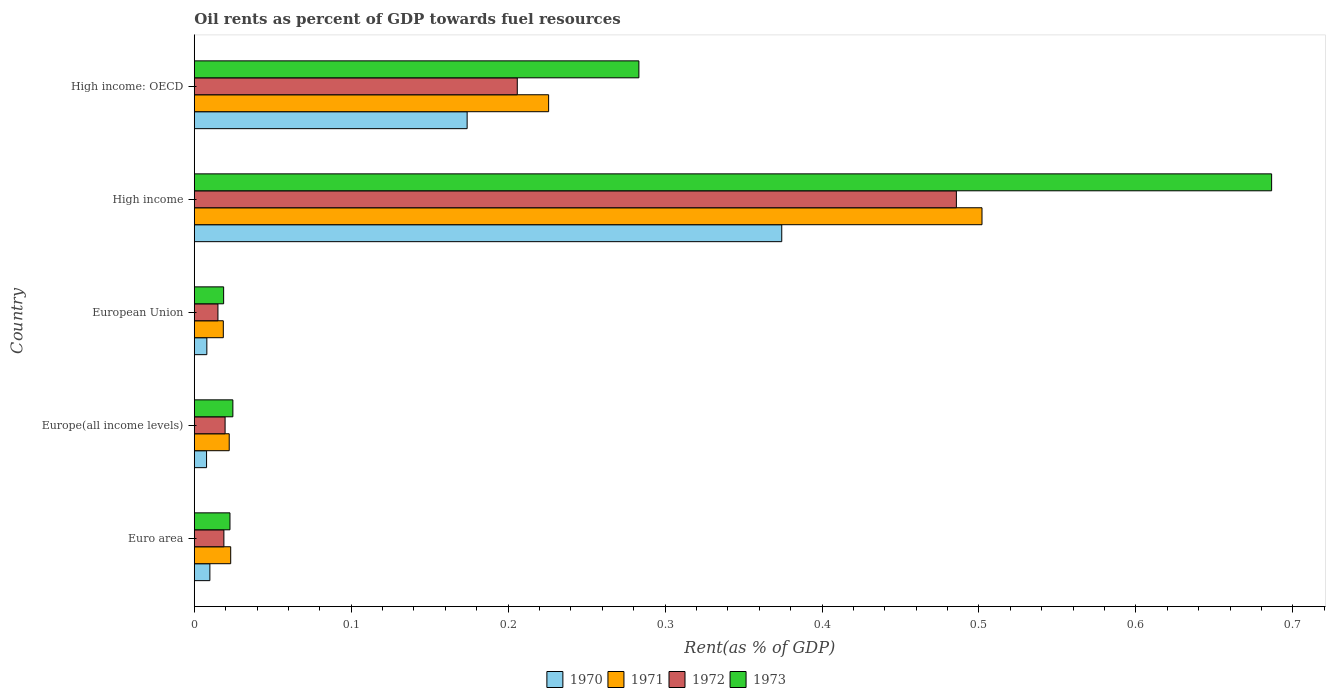How many different coloured bars are there?
Offer a very short reply. 4. Are the number of bars on each tick of the Y-axis equal?
Make the answer very short. Yes. What is the oil rent in 1971 in Euro area?
Offer a very short reply. 0.02. Across all countries, what is the maximum oil rent in 1973?
Offer a terse response. 0.69. Across all countries, what is the minimum oil rent in 1971?
Give a very brief answer. 0.02. What is the total oil rent in 1972 in the graph?
Offer a very short reply. 0.75. What is the difference between the oil rent in 1971 in Euro area and that in High income?
Provide a short and direct response. -0.48. What is the difference between the oil rent in 1970 in High income: OECD and the oil rent in 1973 in Europe(all income levels)?
Provide a short and direct response. 0.15. What is the average oil rent in 1973 per country?
Ensure brevity in your answer.  0.21. What is the difference between the oil rent in 1972 and oil rent in 1973 in High income?
Your answer should be compact. -0.2. In how many countries, is the oil rent in 1973 greater than 0.18 %?
Make the answer very short. 2. What is the ratio of the oil rent in 1970 in Euro area to that in Europe(all income levels)?
Ensure brevity in your answer.  1.27. Is the difference between the oil rent in 1972 in Europe(all income levels) and High income greater than the difference between the oil rent in 1973 in Europe(all income levels) and High income?
Make the answer very short. Yes. What is the difference between the highest and the second highest oil rent in 1970?
Ensure brevity in your answer.  0.2. What is the difference between the highest and the lowest oil rent in 1972?
Keep it short and to the point. 0.47. In how many countries, is the oil rent in 1971 greater than the average oil rent in 1971 taken over all countries?
Provide a succinct answer. 2. Is the sum of the oil rent in 1970 in Europe(all income levels) and High income: OECD greater than the maximum oil rent in 1971 across all countries?
Ensure brevity in your answer.  No. Is it the case that in every country, the sum of the oil rent in 1971 and oil rent in 1972 is greater than the sum of oil rent in 1973 and oil rent in 1970?
Ensure brevity in your answer.  No. What does the 4th bar from the top in High income: OECD represents?
Your answer should be compact. 1970. What does the 2nd bar from the bottom in Euro area represents?
Make the answer very short. 1971. Is it the case that in every country, the sum of the oil rent in 1971 and oil rent in 1973 is greater than the oil rent in 1970?
Your answer should be very brief. Yes. How many bars are there?
Your answer should be very brief. 20. Are the values on the major ticks of X-axis written in scientific E-notation?
Offer a very short reply. No. Does the graph contain grids?
Make the answer very short. No. Where does the legend appear in the graph?
Offer a terse response. Bottom center. How many legend labels are there?
Your answer should be very brief. 4. How are the legend labels stacked?
Offer a terse response. Horizontal. What is the title of the graph?
Make the answer very short. Oil rents as percent of GDP towards fuel resources. Does "1990" appear as one of the legend labels in the graph?
Offer a very short reply. No. What is the label or title of the X-axis?
Provide a short and direct response. Rent(as % of GDP). What is the Rent(as % of GDP) in 1970 in Euro area?
Your answer should be compact. 0.01. What is the Rent(as % of GDP) in 1971 in Euro area?
Your answer should be compact. 0.02. What is the Rent(as % of GDP) in 1972 in Euro area?
Give a very brief answer. 0.02. What is the Rent(as % of GDP) in 1973 in Euro area?
Provide a succinct answer. 0.02. What is the Rent(as % of GDP) in 1970 in Europe(all income levels)?
Provide a succinct answer. 0.01. What is the Rent(as % of GDP) in 1971 in Europe(all income levels)?
Provide a succinct answer. 0.02. What is the Rent(as % of GDP) of 1972 in Europe(all income levels)?
Provide a short and direct response. 0.02. What is the Rent(as % of GDP) in 1973 in Europe(all income levels)?
Offer a very short reply. 0.02. What is the Rent(as % of GDP) of 1970 in European Union?
Ensure brevity in your answer.  0.01. What is the Rent(as % of GDP) in 1971 in European Union?
Your answer should be very brief. 0.02. What is the Rent(as % of GDP) of 1972 in European Union?
Make the answer very short. 0.02. What is the Rent(as % of GDP) of 1973 in European Union?
Keep it short and to the point. 0.02. What is the Rent(as % of GDP) of 1970 in High income?
Offer a terse response. 0.37. What is the Rent(as % of GDP) of 1971 in High income?
Offer a terse response. 0.5. What is the Rent(as % of GDP) in 1972 in High income?
Offer a terse response. 0.49. What is the Rent(as % of GDP) in 1973 in High income?
Ensure brevity in your answer.  0.69. What is the Rent(as % of GDP) in 1970 in High income: OECD?
Your response must be concise. 0.17. What is the Rent(as % of GDP) of 1971 in High income: OECD?
Offer a terse response. 0.23. What is the Rent(as % of GDP) in 1972 in High income: OECD?
Offer a terse response. 0.21. What is the Rent(as % of GDP) in 1973 in High income: OECD?
Your response must be concise. 0.28. Across all countries, what is the maximum Rent(as % of GDP) in 1970?
Offer a very short reply. 0.37. Across all countries, what is the maximum Rent(as % of GDP) in 1971?
Your answer should be compact. 0.5. Across all countries, what is the maximum Rent(as % of GDP) in 1972?
Provide a short and direct response. 0.49. Across all countries, what is the maximum Rent(as % of GDP) in 1973?
Your answer should be very brief. 0.69. Across all countries, what is the minimum Rent(as % of GDP) in 1970?
Make the answer very short. 0.01. Across all countries, what is the minimum Rent(as % of GDP) in 1971?
Make the answer very short. 0.02. Across all countries, what is the minimum Rent(as % of GDP) of 1972?
Make the answer very short. 0.02. Across all countries, what is the minimum Rent(as % of GDP) in 1973?
Your response must be concise. 0.02. What is the total Rent(as % of GDP) in 1970 in the graph?
Make the answer very short. 0.57. What is the total Rent(as % of GDP) in 1971 in the graph?
Provide a succinct answer. 0.79. What is the total Rent(as % of GDP) of 1972 in the graph?
Give a very brief answer. 0.74. What is the total Rent(as % of GDP) in 1973 in the graph?
Your answer should be very brief. 1.04. What is the difference between the Rent(as % of GDP) of 1970 in Euro area and that in Europe(all income levels)?
Ensure brevity in your answer.  0. What is the difference between the Rent(as % of GDP) in 1971 in Euro area and that in Europe(all income levels)?
Provide a short and direct response. 0. What is the difference between the Rent(as % of GDP) of 1972 in Euro area and that in Europe(all income levels)?
Make the answer very short. -0. What is the difference between the Rent(as % of GDP) of 1973 in Euro area and that in Europe(all income levels)?
Offer a very short reply. -0. What is the difference between the Rent(as % of GDP) of 1970 in Euro area and that in European Union?
Ensure brevity in your answer.  0. What is the difference between the Rent(as % of GDP) of 1971 in Euro area and that in European Union?
Offer a terse response. 0. What is the difference between the Rent(as % of GDP) in 1972 in Euro area and that in European Union?
Offer a terse response. 0. What is the difference between the Rent(as % of GDP) in 1973 in Euro area and that in European Union?
Offer a very short reply. 0. What is the difference between the Rent(as % of GDP) in 1970 in Euro area and that in High income?
Provide a succinct answer. -0.36. What is the difference between the Rent(as % of GDP) in 1971 in Euro area and that in High income?
Give a very brief answer. -0.48. What is the difference between the Rent(as % of GDP) in 1972 in Euro area and that in High income?
Your answer should be very brief. -0.47. What is the difference between the Rent(as % of GDP) of 1973 in Euro area and that in High income?
Give a very brief answer. -0.66. What is the difference between the Rent(as % of GDP) in 1970 in Euro area and that in High income: OECD?
Make the answer very short. -0.16. What is the difference between the Rent(as % of GDP) of 1971 in Euro area and that in High income: OECD?
Your answer should be compact. -0.2. What is the difference between the Rent(as % of GDP) in 1972 in Euro area and that in High income: OECD?
Ensure brevity in your answer.  -0.19. What is the difference between the Rent(as % of GDP) in 1973 in Euro area and that in High income: OECD?
Ensure brevity in your answer.  -0.26. What is the difference between the Rent(as % of GDP) of 1970 in Europe(all income levels) and that in European Union?
Offer a very short reply. -0. What is the difference between the Rent(as % of GDP) of 1971 in Europe(all income levels) and that in European Union?
Provide a short and direct response. 0. What is the difference between the Rent(as % of GDP) in 1972 in Europe(all income levels) and that in European Union?
Offer a very short reply. 0. What is the difference between the Rent(as % of GDP) in 1973 in Europe(all income levels) and that in European Union?
Provide a short and direct response. 0.01. What is the difference between the Rent(as % of GDP) in 1970 in Europe(all income levels) and that in High income?
Offer a very short reply. -0.37. What is the difference between the Rent(as % of GDP) in 1971 in Europe(all income levels) and that in High income?
Keep it short and to the point. -0.48. What is the difference between the Rent(as % of GDP) in 1972 in Europe(all income levels) and that in High income?
Offer a terse response. -0.47. What is the difference between the Rent(as % of GDP) in 1973 in Europe(all income levels) and that in High income?
Your answer should be compact. -0.66. What is the difference between the Rent(as % of GDP) of 1970 in Europe(all income levels) and that in High income: OECD?
Ensure brevity in your answer.  -0.17. What is the difference between the Rent(as % of GDP) in 1971 in Europe(all income levels) and that in High income: OECD?
Provide a short and direct response. -0.2. What is the difference between the Rent(as % of GDP) of 1972 in Europe(all income levels) and that in High income: OECD?
Provide a succinct answer. -0.19. What is the difference between the Rent(as % of GDP) of 1973 in Europe(all income levels) and that in High income: OECD?
Make the answer very short. -0.26. What is the difference between the Rent(as % of GDP) of 1970 in European Union and that in High income?
Your answer should be very brief. -0.37. What is the difference between the Rent(as % of GDP) in 1971 in European Union and that in High income?
Offer a terse response. -0.48. What is the difference between the Rent(as % of GDP) of 1972 in European Union and that in High income?
Ensure brevity in your answer.  -0.47. What is the difference between the Rent(as % of GDP) in 1973 in European Union and that in High income?
Provide a short and direct response. -0.67. What is the difference between the Rent(as % of GDP) in 1970 in European Union and that in High income: OECD?
Provide a succinct answer. -0.17. What is the difference between the Rent(as % of GDP) of 1971 in European Union and that in High income: OECD?
Your answer should be very brief. -0.21. What is the difference between the Rent(as % of GDP) in 1972 in European Union and that in High income: OECD?
Your response must be concise. -0.19. What is the difference between the Rent(as % of GDP) in 1973 in European Union and that in High income: OECD?
Your answer should be very brief. -0.26. What is the difference between the Rent(as % of GDP) of 1970 in High income and that in High income: OECD?
Your answer should be very brief. 0.2. What is the difference between the Rent(as % of GDP) in 1971 in High income and that in High income: OECD?
Offer a terse response. 0.28. What is the difference between the Rent(as % of GDP) of 1972 in High income and that in High income: OECD?
Make the answer very short. 0.28. What is the difference between the Rent(as % of GDP) in 1973 in High income and that in High income: OECD?
Provide a succinct answer. 0.4. What is the difference between the Rent(as % of GDP) of 1970 in Euro area and the Rent(as % of GDP) of 1971 in Europe(all income levels)?
Your answer should be very brief. -0.01. What is the difference between the Rent(as % of GDP) in 1970 in Euro area and the Rent(as % of GDP) in 1972 in Europe(all income levels)?
Ensure brevity in your answer.  -0.01. What is the difference between the Rent(as % of GDP) of 1970 in Euro area and the Rent(as % of GDP) of 1973 in Europe(all income levels)?
Provide a short and direct response. -0.01. What is the difference between the Rent(as % of GDP) of 1971 in Euro area and the Rent(as % of GDP) of 1972 in Europe(all income levels)?
Your answer should be very brief. 0. What is the difference between the Rent(as % of GDP) in 1971 in Euro area and the Rent(as % of GDP) in 1973 in Europe(all income levels)?
Make the answer very short. -0. What is the difference between the Rent(as % of GDP) of 1972 in Euro area and the Rent(as % of GDP) of 1973 in Europe(all income levels)?
Your response must be concise. -0.01. What is the difference between the Rent(as % of GDP) of 1970 in Euro area and the Rent(as % of GDP) of 1971 in European Union?
Offer a very short reply. -0.01. What is the difference between the Rent(as % of GDP) in 1970 in Euro area and the Rent(as % of GDP) in 1972 in European Union?
Give a very brief answer. -0.01. What is the difference between the Rent(as % of GDP) in 1970 in Euro area and the Rent(as % of GDP) in 1973 in European Union?
Your answer should be compact. -0.01. What is the difference between the Rent(as % of GDP) in 1971 in Euro area and the Rent(as % of GDP) in 1972 in European Union?
Provide a succinct answer. 0.01. What is the difference between the Rent(as % of GDP) of 1971 in Euro area and the Rent(as % of GDP) of 1973 in European Union?
Ensure brevity in your answer.  0. What is the difference between the Rent(as % of GDP) in 1970 in Euro area and the Rent(as % of GDP) in 1971 in High income?
Make the answer very short. -0.49. What is the difference between the Rent(as % of GDP) in 1970 in Euro area and the Rent(as % of GDP) in 1972 in High income?
Make the answer very short. -0.48. What is the difference between the Rent(as % of GDP) in 1970 in Euro area and the Rent(as % of GDP) in 1973 in High income?
Provide a succinct answer. -0.68. What is the difference between the Rent(as % of GDP) of 1971 in Euro area and the Rent(as % of GDP) of 1972 in High income?
Provide a succinct answer. -0.46. What is the difference between the Rent(as % of GDP) in 1971 in Euro area and the Rent(as % of GDP) in 1973 in High income?
Make the answer very short. -0.66. What is the difference between the Rent(as % of GDP) of 1972 in Euro area and the Rent(as % of GDP) of 1973 in High income?
Make the answer very short. -0.67. What is the difference between the Rent(as % of GDP) in 1970 in Euro area and the Rent(as % of GDP) in 1971 in High income: OECD?
Provide a succinct answer. -0.22. What is the difference between the Rent(as % of GDP) of 1970 in Euro area and the Rent(as % of GDP) of 1972 in High income: OECD?
Keep it short and to the point. -0.2. What is the difference between the Rent(as % of GDP) in 1970 in Euro area and the Rent(as % of GDP) in 1973 in High income: OECD?
Provide a succinct answer. -0.27. What is the difference between the Rent(as % of GDP) of 1971 in Euro area and the Rent(as % of GDP) of 1972 in High income: OECD?
Provide a succinct answer. -0.18. What is the difference between the Rent(as % of GDP) in 1971 in Euro area and the Rent(as % of GDP) in 1973 in High income: OECD?
Your answer should be compact. -0.26. What is the difference between the Rent(as % of GDP) in 1972 in Euro area and the Rent(as % of GDP) in 1973 in High income: OECD?
Your answer should be compact. -0.26. What is the difference between the Rent(as % of GDP) of 1970 in Europe(all income levels) and the Rent(as % of GDP) of 1971 in European Union?
Make the answer very short. -0.01. What is the difference between the Rent(as % of GDP) in 1970 in Europe(all income levels) and the Rent(as % of GDP) in 1972 in European Union?
Provide a short and direct response. -0.01. What is the difference between the Rent(as % of GDP) in 1970 in Europe(all income levels) and the Rent(as % of GDP) in 1973 in European Union?
Offer a very short reply. -0.01. What is the difference between the Rent(as % of GDP) in 1971 in Europe(all income levels) and the Rent(as % of GDP) in 1972 in European Union?
Provide a succinct answer. 0.01. What is the difference between the Rent(as % of GDP) of 1971 in Europe(all income levels) and the Rent(as % of GDP) of 1973 in European Union?
Offer a terse response. 0. What is the difference between the Rent(as % of GDP) of 1972 in Europe(all income levels) and the Rent(as % of GDP) of 1973 in European Union?
Provide a succinct answer. 0. What is the difference between the Rent(as % of GDP) in 1970 in Europe(all income levels) and the Rent(as % of GDP) in 1971 in High income?
Provide a succinct answer. -0.49. What is the difference between the Rent(as % of GDP) of 1970 in Europe(all income levels) and the Rent(as % of GDP) of 1972 in High income?
Offer a terse response. -0.48. What is the difference between the Rent(as % of GDP) in 1970 in Europe(all income levels) and the Rent(as % of GDP) in 1973 in High income?
Your answer should be compact. -0.68. What is the difference between the Rent(as % of GDP) of 1971 in Europe(all income levels) and the Rent(as % of GDP) of 1972 in High income?
Your answer should be compact. -0.46. What is the difference between the Rent(as % of GDP) in 1971 in Europe(all income levels) and the Rent(as % of GDP) in 1973 in High income?
Offer a terse response. -0.66. What is the difference between the Rent(as % of GDP) in 1972 in Europe(all income levels) and the Rent(as % of GDP) in 1973 in High income?
Provide a short and direct response. -0.67. What is the difference between the Rent(as % of GDP) of 1970 in Europe(all income levels) and the Rent(as % of GDP) of 1971 in High income: OECD?
Give a very brief answer. -0.22. What is the difference between the Rent(as % of GDP) of 1970 in Europe(all income levels) and the Rent(as % of GDP) of 1972 in High income: OECD?
Provide a succinct answer. -0.2. What is the difference between the Rent(as % of GDP) in 1970 in Europe(all income levels) and the Rent(as % of GDP) in 1973 in High income: OECD?
Your response must be concise. -0.28. What is the difference between the Rent(as % of GDP) in 1971 in Europe(all income levels) and the Rent(as % of GDP) in 1972 in High income: OECD?
Provide a short and direct response. -0.18. What is the difference between the Rent(as % of GDP) of 1971 in Europe(all income levels) and the Rent(as % of GDP) of 1973 in High income: OECD?
Your answer should be compact. -0.26. What is the difference between the Rent(as % of GDP) of 1972 in Europe(all income levels) and the Rent(as % of GDP) of 1973 in High income: OECD?
Offer a very short reply. -0.26. What is the difference between the Rent(as % of GDP) of 1970 in European Union and the Rent(as % of GDP) of 1971 in High income?
Ensure brevity in your answer.  -0.49. What is the difference between the Rent(as % of GDP) in 1970 in European Union and the Rent(as % of GDP) in 1972 in High income?
Offer a terse response. -0.48. What is the difference between the Rent(as % of GDP) in 1970 in European Union and the Rent(as % of GDP) in 1973 in High income?
Provide a short and direct response. -0.68. What is the difference between the Rent(as % of GDP) of 1971 in European Union and the Rent(as % of GDP) of 1972 in High income?
Your response must be concise. -0.47. What is the difference between the Rent(as % of GDP) of 1971 in European Union and the Rent(as % of GDP) of 1973 in High income?
Provide a succinct answer. -0.67. What is the difference between the Rent(as % of GDP) in 1972 in European Union and the Rent(as % of GDP) in 1973 in High income?
Make the answer very short. -0.67. What is the difference between the Rent(as % of GDP) of 1970 in European Union and the Rent(as % of GDP) of 1971 in High income: OECD?
Your answer should be compact. -0.22. What is the difference between the Rent(as % of GDP) of 1970 in European Union and the Rent(as % of GDP) of 1972 in High income: OECD?
Offer a very short reply. -0.2. What is the difference between the Rent(as % of GDP) of 1970 in European Union and the Rent(as % of GDP) of 1973 in High income: OECD?
Your answer should be compact. -0.28. What is the difference between the Rent(as % of GDP) in 1971 in European Union and the Rent(as % of GDP) in 1972 in High income: OECD?
Offer a very short reply. -0.19. What is the difference between the Rent(as % of GDP) of 1971 in European Union and the Rent(as % of GDP) of 1973 in High income: OECD?
Offer a very short reply. -0.26. What is the difference between the Rent(as % of GDP) in 1972 in European Union and the Rent(as % of GDP) in 1973 in High income: OECD?
Make the answer very short. -0.27. What is the difference between the Rent(as % of GDP) in 1970 in High income and the Rent(as % of GDP) in 1971 in High income: OECD?
Your answer should be compact. 0.15. What is the difference between the Rent(as % of GDP) of 1970 in High income and the Rent(as % of GDP) of 1972 in High income: OECD?
Offer a very short reply. 0.17. What is the difference between the Rent(as % of GDP) in 1970 in High income and the Rent(as % of GDP) in 1973 in High income: OECD?
Your answer should be compact. 0.09. What is the difference between the Rent(as % of GDP) of 1971 in High income and the Rent(as % of GDP) of 1972 in High income: OECD?
Your response must be concise. 0.3. What is the difference between the Rent(as % of GDP) of 1971 in High income and the Rent(as % of GDP) of 1973 in High income: OECD?
Provide a short and direct response. 0.22. What is the difference between the Rent(as % of GDP) of 1972 in High income and the Rent(as % of GDP) of 1973 in High income: OECD?
Keep it short and to the point. 0.2. What is the average Rent(as % of GDP) of 1970 per country?
Offer a terse response. 0.11. What is the average Rent(as % of GDP) of 1971 per country?
Keep it short and to the point. 0.16. What is the average Rent(as % of GDP) in 1972 per country?
Keep it short and to the point. 0.15. What is the average Rent(as % of GDP) in 1973 per country?
Your answer should be very brief. 0.21. What is the difference between the Rent(as % of GDP) in 1970 and Rent(as % of GDP) in 1971 in Euro area?
Provide a short and direct response. -0.01. What is the difference between the Rent(as % of GDP) of 1970 and Rent(as % of GDP) of 1972 in Euro area?
Your answer should be very brief. -0.01. What is the difference between the Rent(as % of GDP) of 1970 and Rent(as % of GDP) of 1973 in Euro area?
Provide a succinct answer. -0.01. What is the difference between the Rent(as % of GDP) in 1971 and Rent(as % of GDP) in 1972 in Euro area?
Keep it short and to the point. 0. What is the difference between the Rent(as % of GDP) of 1971 and Rent(as % of GDP) of 1973 in Euro area?
Make the answer very short. 0. What is the difference between the Rent(as % of GDP) in 1972 and Rent(as % of GDP) in 1973 in Euro area?
Provide a short and direct response. -0. What is the difference between the Rent(as % of GDP) of 1970 and Rent(as % of GDP) of 1971 in Europe(all income levels)?
Give a very brief answer. -0.01. What is the difference between the Rent(as % of GDP) in 1970 and Rent(as % of GDP) in 1972 in Europe(all income levels)?
Offer a terse response. -0.01. What is the difference between the Rent(as % of GDP) of 1970 and Rent(as % of GDP) of 1973 in Europe(all income levels)?
Provide a short and direct response. -0.02. What is the difference between the Rent(as % of GDP) in 1971 and Rent(as % of GDP) in 1972 in Europe(all income levels)?
Provide a succinct answer. 0. What is the difference between the Rent(as % of GDP) in 1971 and Rent(as % of GDP) in 1973 in Europe(all income levels)?
Provide a succinct answer. -0. What is the difference between the Rent(as % of GDP) of 1972 and Rent(as % of GDP) of 1973 in Europe(all income levels)?
Offer a terse response. -0.01. What is the difference between the Rent(as % of GDP) in 1970 and Rent(as % of GDP) in 1971 in European Union?
Offer a very short reply. -0.01. What is the difference between the Rent(as % of GDP) in 1970 and Rent(as % of GDP) in 1972 in European Union?
Provide a succinct answer. -0.01. What is the difference between the Rent(as % of GDP) in 1970 and Rent(as % of GDP) in 1973 in European Union?
Your answer should be compact. -0.01. What is the difference between the Rent(as % of GDP) in 1971 and Rent(as % of GDP) in 1972 in European Union?
Your response must be concise. 0. What is the difference between the Rent(as % of GDP) in 1971 and Rent(as % of GDP) in 1973 in European Union?
Offer a terse response. -0. What is the difference between the Rent(as % of GDP) in 1972 and Rent(as % of GDP) in 1973 in European Union?
Make the answer very short. -0. What is the difference between the Rent(as % of GDP) of 1970 and Rent(as % of GDP) of 1971 in High income?
Offer a very short reply. -0.13. What is the difference between the Rent(as % of GDP) in 1970 and Rent(as % of GDP) in 1972 in High income?
Give a very brief answer. -0.11. What is the difference between the Rent(as % of GDP) in 1970 and Rent(as % of GDP) in 1973 in High income?
Give a very brief answer. -0.31. What is the difference between the Rent(as % of GDP) of 1971 and Rent(as % of GDP) of 1972 in High income?
Your answer should be compact. 0.02. What is the difference between the Rent(as % of GDP) of 1971 and Rent(as % of GDP) of 1973 in High income?
Provide a short and direct response. -0.18. What is the difference between the Rent(as % of GDP) in 1972 and Rent(as % of GDP) in 1973 in High income?
Your response must be concise. -0.2. What is the difference between the Rent(as % of GDP) in 1970 and Rent(as % of GDP) in 1971 in High income: OECD?
Provide a succinct answer. -0.05. What is the difference between the Rent(as % of GDP) of 1970 and Rent(as % of GDP) of 1972 in High income: OECD?
Ensure brevity in your answer.  -0.03. What is the difference between the Rent(as % of GDP) in 1970 and Rent(as % of GDP) in 1973 in High income: OECD?
Provide a succinct answer. -0.11. What is the difference between the Rent(as % of GDP) of 1971 and Rent(as % of GDP) of 1972 in High income: OECD?
Provide a short and direct response. 0.02. What is the difference between the Rent(as % of GDP) of 1971 and Rent(as % of GDP) of 1973 in High income: OECD?
Offer a very short reply. -0.06. What is the difference between the Rent(as % of GDP) of 1972 and Rent(as % of GDP) of 1973 in High income: OECD?
Make the answer very short. -0.08. What is the ratio of the Rent(as % of GDP) in 1970 in Euro area to that in Europe(all income levels)?
Your answer should be very brief. 1.27. What is the ratio of the Rent(as % of GDP) in 1971 in Euro area to that in Europe(all income levels)?
Offer a very short reply. 1.04. What is the ratio of the Rent(as % of GDP) of 1972 in Euro area to that in Europe(all income levels)?
Give a very brief answer. 0.96. What is the ratio of the Rent(as % of GDP) of 1973 in Euro area to that in Europe(all income levels)?
Provide a short and direct response. 0.92. What is the ratio of the Rent(as % of GDP) in 1970 in Euro area to that in European Union?
Give a very brief answer. 1.24. What is the ratio of the Rent(as % of GDP) in 1971 in Euro area to that in European Union?
Give a very brief answer. 1.25. What is the ratio of the Rent(as % of GDP) in 1972 in Euro area to that in European Union?
Offer a terse response. 1.25. What is the ratio of the Rent(as % of GDP) in 1973 in Euro area to that in European Union?
Give a very brief answer. 1.22. What is the ratio of the Rent(as % of GDP) in 1970 in Euro area to that in High income?
Ensure brevity in your answer.  0.03. What is the ratio of the Rent(as % of GDP) of 1971 in Euro area to that in High income?
Make the answer very short. 0.05. What is the ratio of the Rent(as % of GDP) in 1972 in Euro area to that in High income?
Keep it short and to the point. 0.04. What is the ratio of the Rent(as % of GDP) in 1973 in Euro area to that in High income?
Make the answer very short. 0.03. What is the ratio of the Rent(as % of GDP) of 1970 in Euro area to that in High income: OECD?
Give a very brief answer. 0.06. What is the ratio of the Rent(as % of GDP) of 1971 in Euro area to that in High income: OECD?
Your answer should be compact. 0.1. What is the ratio of the Rent(as % of GDP) in 1972 in Euro area to that in High income: OECD?
Your response must be concise. 0.09. What is the ratio of the Rent(as % of GDP) of 1973 in Euro area to that in High income: OECD?
Your answer should be compact. 0.08. What is the ratio of the Rent(as % of GDP) of 1970 in Europe(all income levels) to that in European Union?
Provide a short and direct response. 0.98. What is the ratio of the Rent(as % of GDP) of 1971 in Europe(all income levels) to that in European Union?
Provide a succinct answer. 1.2. What is the ratio of the Rent(as % of GDP) of 1972 in Europe(all income levels) to that in European Union?
Your answer should be compact. 1.3. What is the ratio of the Rent(as % of GDP) in 1973 in Europe(all income levels) to that in European Union?
Offer a very short reply. 1.31. What is the ratio of the Rent(as % of GDP) in 1970 in Europe(all income levels) to that in High income?
Offer a terse response. 0.02. What is the ratio of the Rent(as % of GDP) of 1971 in Europe(all income levels) to that in High income?
Your answer should be very brief. 0.04. What is the ratio of the Rent(as % of GDP) in 1972 in Europe(all income levels) to that in High income?
Provide a short and direct response. 0.04. What is the ratio of the Rent(as % of GDP) of 1973 in Europe(all income levels) to that in High income?
Your answer should be very brief. 0.04. What is the ratio of the Rent(as % of GDP) in 1970 in Europe(all income levels) to that in High income: OECD?
Your answer should be compact. 0.05. What is the ratio of the Rent(as % of GDP) in 1971 in Europe(all income levels) to that in High income: OECD?
Provide a short and direct response. 0.1. What is the ratio of the Rent(as % of GDP) in 1972 in Europe(all income levels) to that in High income: OECD?
Your answer should be compact. 0.1. What is the ratio of the Rent(as % of GDP) of 1973 in Europe(all income levels) to that in High income: OECD?
Ensure brevity in your answer.  0.09. What is the ratio of the Rent(as % of GDP) of 1970 in European Union to that in High income?
Provide a succinct answer. 0.02. What is the ratio of the Rent(as % of GDP) of 1971 in European Union to that in High income?
Provide a succinct answer. 0.04. What is the ratio of the Rent(as % of GDP) of 1972 in European Union to that in High income?
Keep it short and to the point. 0.03. What is the ratio of the Rent(as % of GDP) of 1973 in European Union to that in High income?
Provide a short and direct response. 0.03. What is the ratio of the Rent(as % of GDP) in 1970 in European Union to that in High income: OECD?
Ensure brevity in your answer.  0.05. What is the ratio of the Rent(as % of GDP) in 1971 in European Union to that in High income: OECD?
Your response must be concise. 0.08. What is the ratio of the Rent(as % of GDP) in 1972 in European Union to that in High income: OECD?
Ensure brevity in your answer.  0.07. What is the ratio of the Rent(as % of GDP) in 1973 in European Union to that in High income: OECD?
Keep it short and to the point. 0.07. What is the ratio of the Rent(as % of GDP) in 1970 in High income to that in High income: OECD?
Keep it short and to the point. 2.15. What is the ratio of the Rent(as % of GDP) of 1971 in High income to that in High income: OECD?
Offer a very short reply. 2.22. What is the ratio of the Rent(as % of GDP) of 1972 in High income to that in High income: OECD?
Offer a very short reply. 2.36. What is the ratio of the Rent(as % of GDP) of 1973 in High income to that in High income: OECD?
Keep it short and to the point. 2.42. What is the difference between the highest and the second highest Rent(as % of GDP) in 1970?
Your answer should be very brief. 0.2. What is the difference between the highest and the second highest Rent(as % of GDP) of 1971?
Make the answer very short. 0.28. What is the difference between the highest and the second highest Rent(as % of GDP) in 1972?
Offer a very short reply. 0.28. What is the difference between the highest and the second highest Rent(as % of GDP) in 1973?
Your answer should be compact. 0.4. What is the difference between the highest and the lowest Rent(as % of GDP) in 1970?
Your answer should be very brief. 0.37. What is the difference between the highest and the lowest Rent(as % of GDP) in 1971?
Offer a very short reply. 0.48. What is the difference between the highest and the lowest Rent(as % of GDP) of 1972?
Provide a succinct answer. 0.47. What is the difference between the highest and the lowest Rent(as % of GDP) of 1973?
Give a very brief answer. 0.67. 